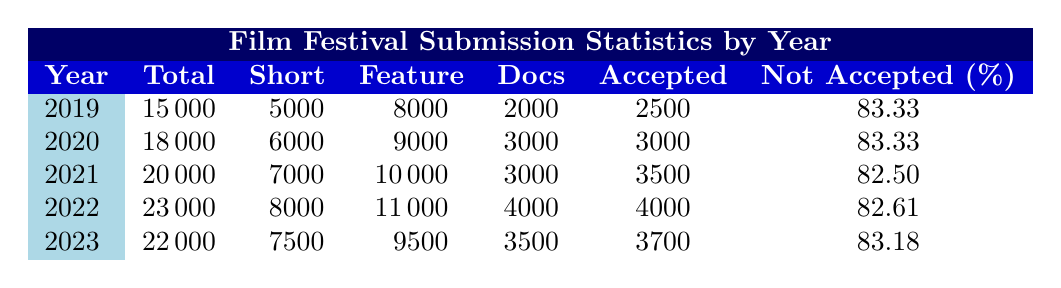What was the total number of submissions in 2020? From the table, under the year 2020, the column for Total Submissions shows a value of 18000.
Answer: 18000 Which year had the highest acceptance rate? The acceptance rate for each year is evident from the Not Accepted Rate column. The calculated acceptance rates for each year are: 2019 (16.67), 2020 (16.67), 2021 (17.50), 2022 (17.39), and 2023 (16.82). The highest acceptance rate (17.50) corresponds to 2021.
Answer: 2021 How many more feature films were submitted in 2021 compared to 2019? The number of Feature Films submitted in 2021 is 10000 and in 2019 is 8000. The difference is 10000 - 8000 = 2000.
Answer: 2000 What is the average number of accepted films from 2019 to 2023? The accepted films over the years are: 2019 (2500), 2020 (3000), 2021 (3500), 2022 (4000), and 2023 (3700). To find the average, sum these numbers: (2500 + 3000 + 3500 + 4000 + 3700) = 16700. There are 5 years, so the average is 16700 / 5 = 3340.
Answer: 3340 Did more documentaries get accepted in 2022 than in 2020? The number of accepted documentaries in 2022 is 4000, and in 2020 is 3000. Since 4000 is greater than 3000, the statement is true.
Answer: Yes How many total films (short, feature, documentaries) were submitted across all years? To find the total films submitted across all years, sum the Total Submissions for each year: 15000 + 18000 + 20000 + 23000 + 22000 = 108000.
Answer: 108000 Which year saw a decrease in total submissions compared to the previous year? Looking at the Total Submissions, 2023 has 22000 submissions while 2022 had 23000, indicating a decrease.
Answer: Yes What was the not accepted rate for the year with the lowest total submissions? The year with the lowest total submissions is 2019 with 15000 submissions and its Not Accepted Rate is 83.33%.
Answer: 83.33% 